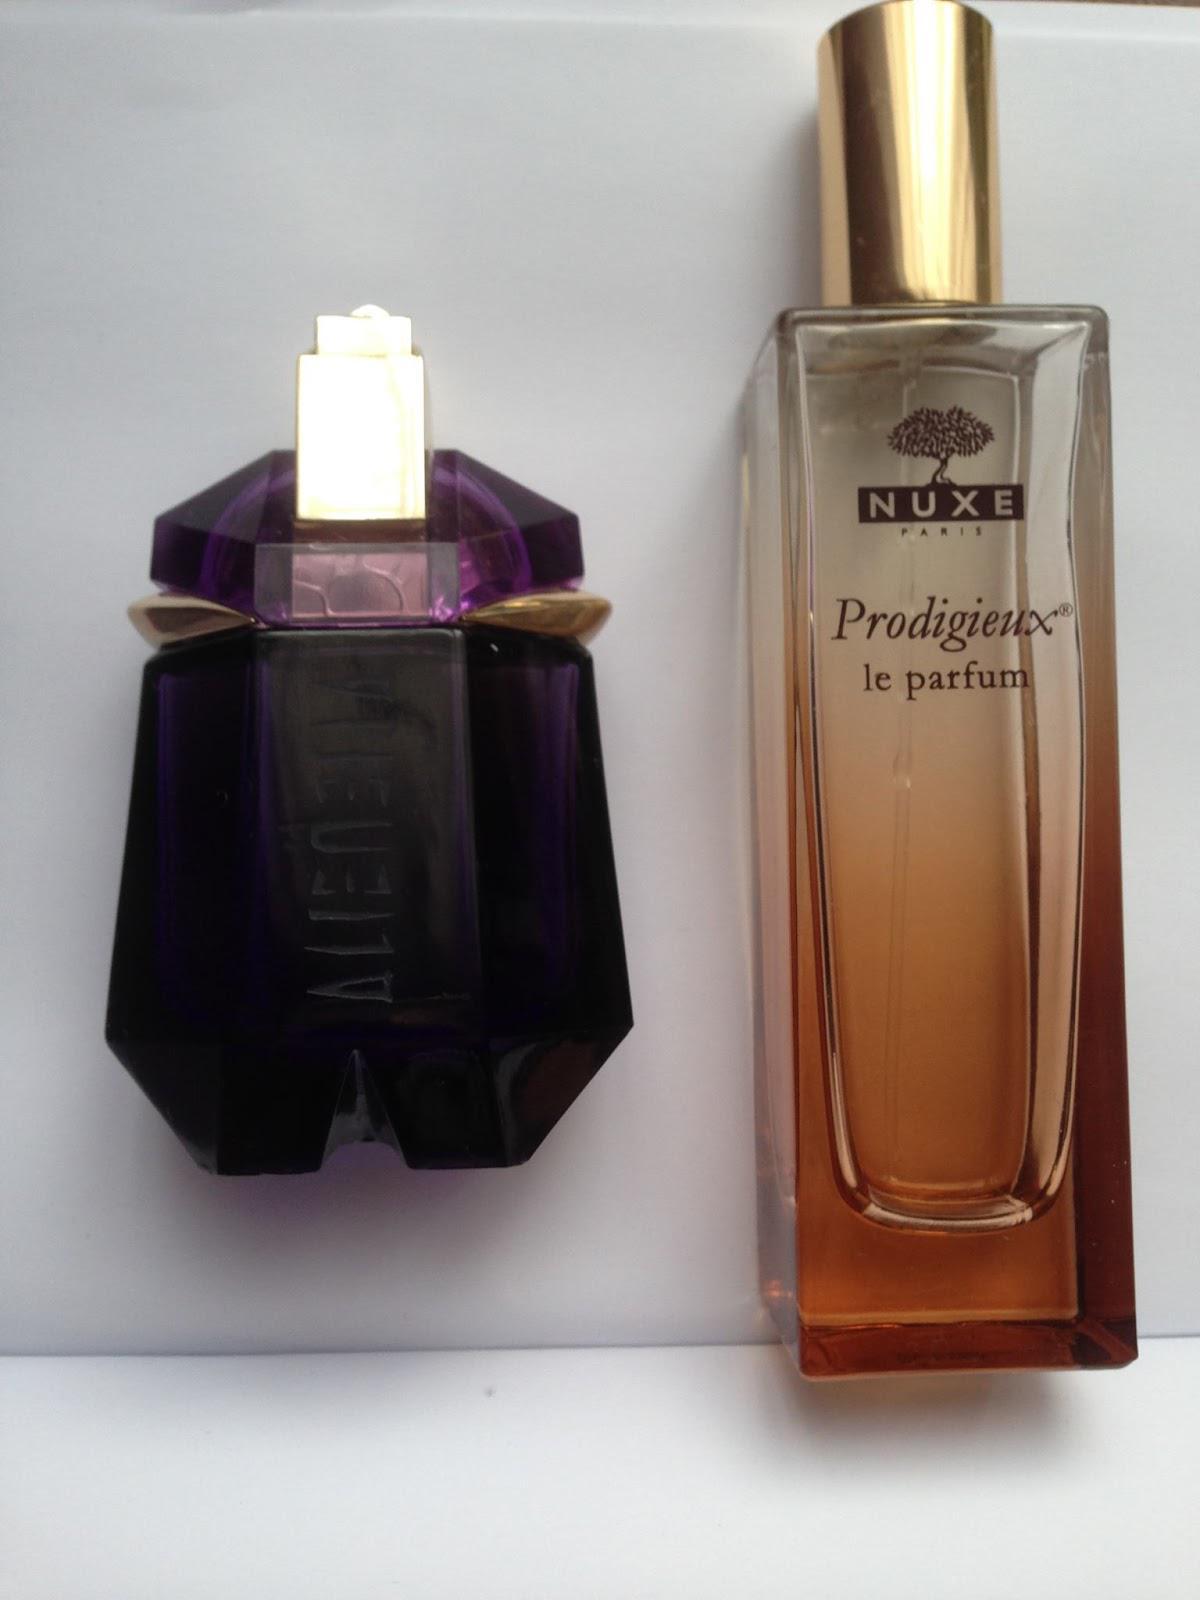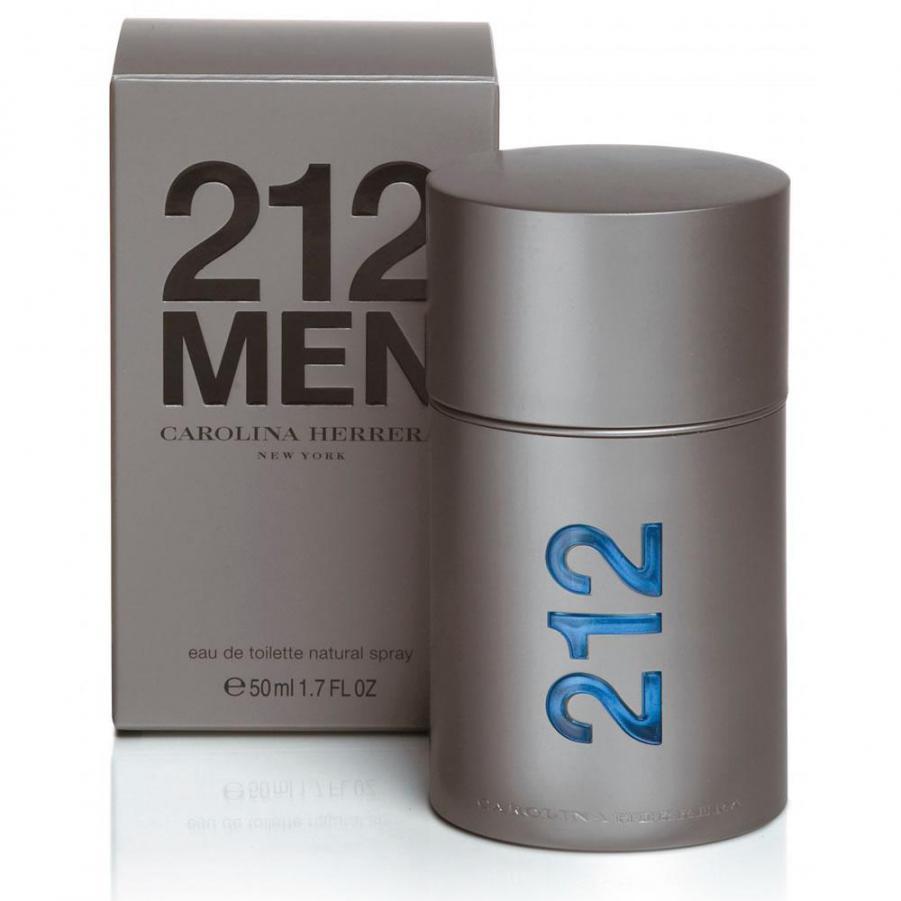The first image is the image on the left, the second image is the image on the right. Assess this claim about the two images: "One image shows a silver cylinder shape next to a silver upright box.". Correct or not? Answer yes or no. Yes. The first image is the image on the left, the second image is the image on the right. Assess this claim about the two images: "There are more containers in the image on the right.". Correct or not? Answer yes or no. No. 